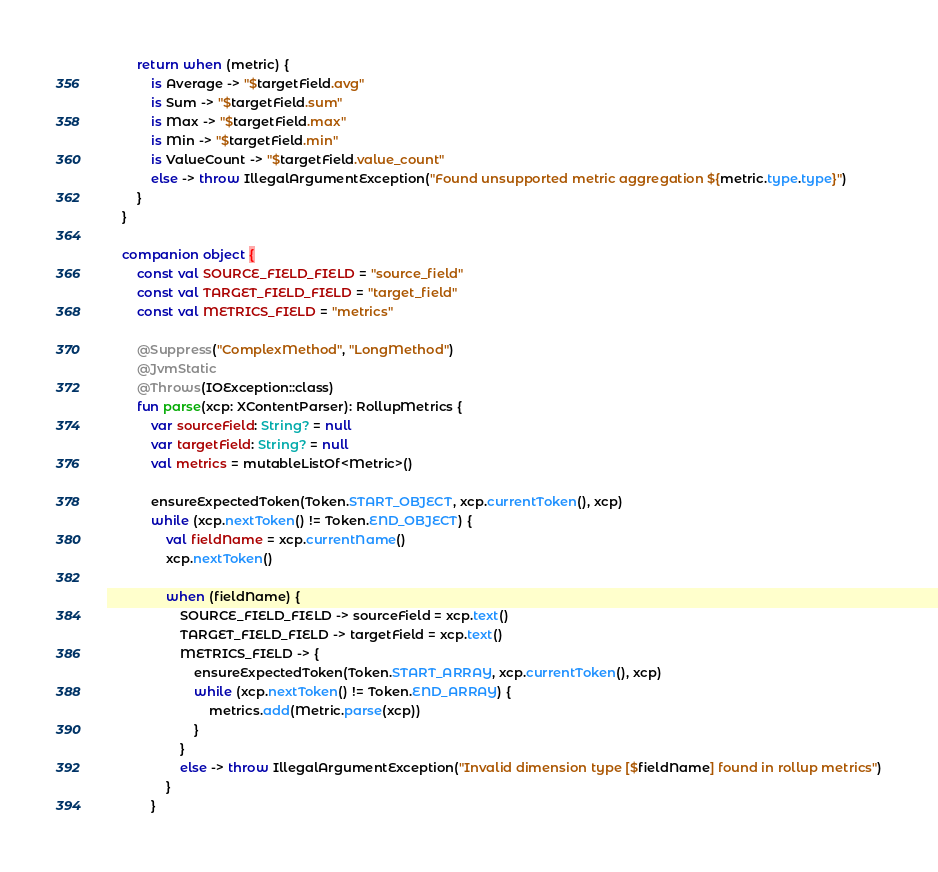<code> <loc_0><loc_0><loc_500><loc_500><_Kotlin_>        return when (metric) {
            is Average -> "$targetField.avg"
            is Sum -> "$targetField.sum"
            is Max -> "$targetField.max"
            is Min -> "$targetField.min"
            is ValueCount -> "$targetField.value_count"
            else -> throw IllegalArgumentException("Found unsupported metric aggregation ${metric.type.type}")
        }
    }

    companion object {
        const val SOURCE_FIELD_FIELD = "source_field"
        const val TARGET_FIELD_FIELD = "target_field"
        const val METRICS_FIELD = "metrics"

        @Suppress("ComplexMethod", "LongMethod")
        @JvmStatic
        @Throws(IOException::class)
        fun parse(xcp: XContentParser): RollupMetrics {
            var sourceField: String? = null
            var targetField: String? = null
            val metrics = mutableListOf<Metric>()

            ensureExpectedToken(Token.START_OBJECT, xcp.currentToken(), xcp)
            while (xcp.nextToken() != Token.END_OBJECT) {
                val fieldName = xcp.currentName()
                xcp.nextToken()

                when (fieldName) {
                    SOURCE_FIELD_FIELD -> sourceField = xcp.text()
                    TARGET_FIELD_FIELD -> targetField = xcp.text()
                    METRICS_FIELD -> {
                        ensureExpectedToken(Token.START_ARRAY, xcp.currentToken(), xcp)
                        while (xcp.nextToken() != Token.END_ARRAY) {
                            metrics.add(Metric.parse(xcp))
                        }
                    }
                    else -> throw IllegalArgumentException("Invalid dimension type [$fieldName] found in rollup metrics")
                }
            }
</code> 